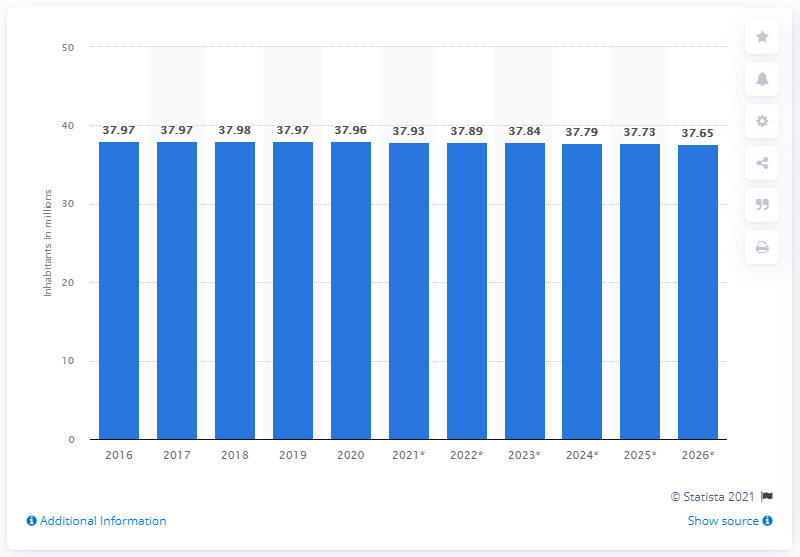Can you tell me how Poland's population has changed over the years according to this graph? The graph depicts a slight but steady decrease in the population of Poland from 2016 to 2026. Starting at around 37.97 million in 2016, the numbers show a gradual decline to reach 37.65 million estimated for 2026, suggesting a consistent demographic trend. 